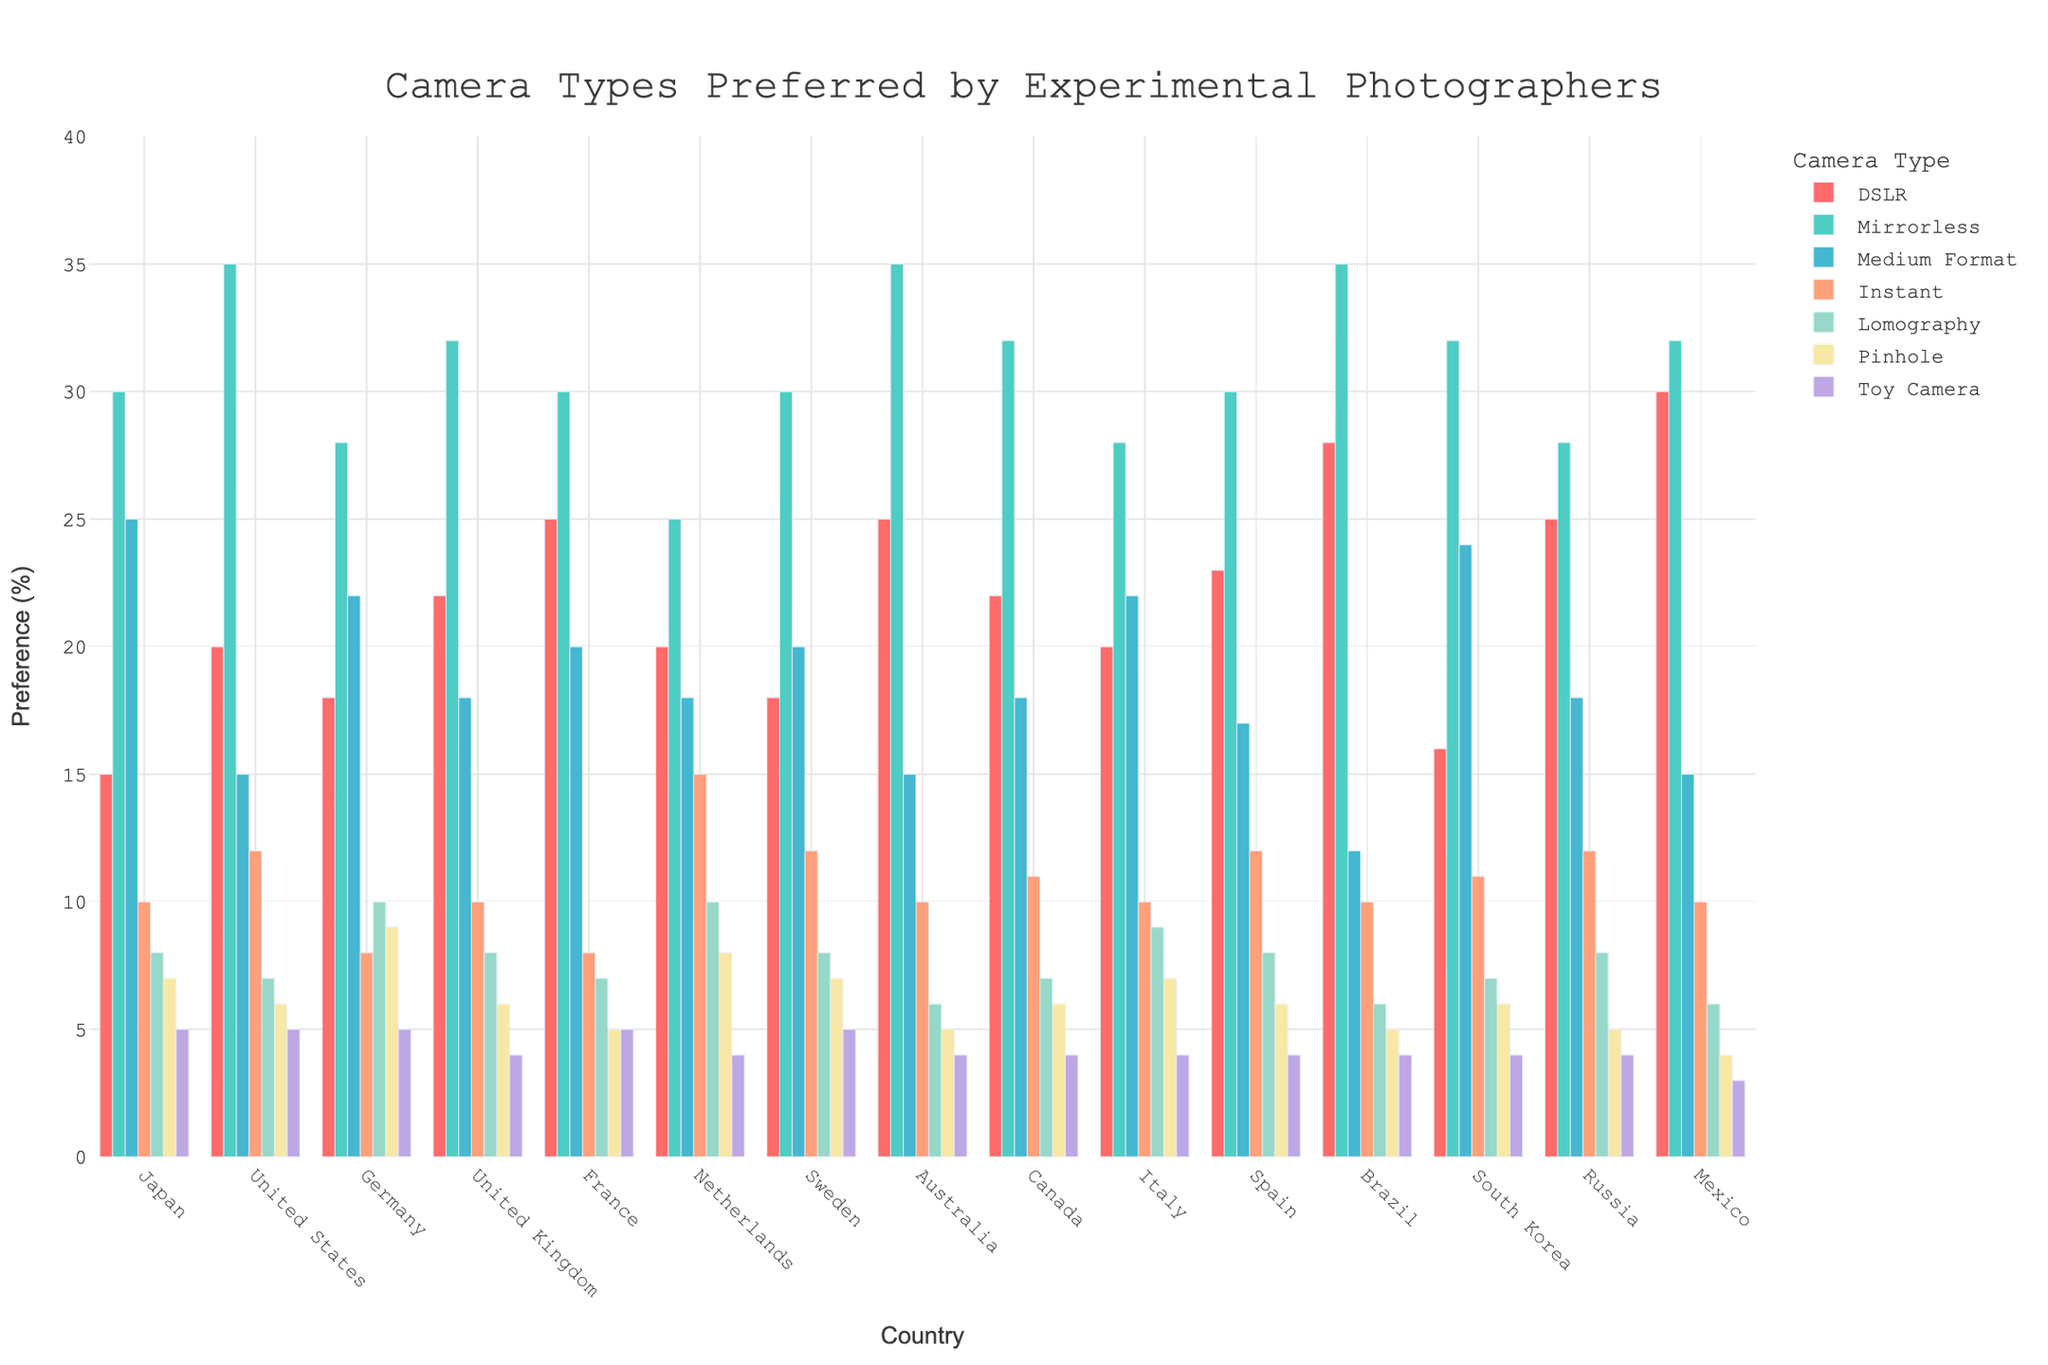Which country has the highest preference for mirrorless cameras? The highest bar in the "Mirrorless" series represents the country with the highest preference. From the chart, the United States and Brazil both have a preference bar reaching 35%.
Answer: United States and Brazil Which camera type is most preferred in Japan? Look for the tallest bar among different camera types for Japan. The "Mirrorless" bar is the tallest in the Japan series at 30%.
Answer: Mirrorless What is the sum of the preferences for Medium Format and Lomography cameras in Germany? Add the preference percentages for Medium Format (22%) and Lomography (10%) in Germany. 22 + 10 = 32.
Answer: 32 Which country has a higher preference for pinhole cameras, Germany or Sweden? Compare the heights of the bars for Pinhole cameras in Germany (9%) and Sweden (7%). The bar for Germany is higher.
Answer: Germany Does the preference for Instant cameras exceed that of Toy Cameras in the United Kingdom? Compare the heights of the bars for Instant (10%) and Toy Cameras (4%) in the United Kingdom. The Instant camera bar is higher.
Answer: Yes Which camera type has the lowest preference in France? Identify the shortest bar in the France series. The "Toy Camera" has a bar height of 5%, which is the lowest.
Answer: Toy Camera How many countries have a preference for DSLR cameras that is greater than 20%? Sum the number of countries where the height of the DSLR bar exceeds 20%. From the chart: United States (20%), United Kingdom (22%), France (25%), Australia (25%), Spain (23%), Brazil (28%), Mexico (30%). There are 7 countries in total.
Answer: 7 What is the difference in preference for Mirrorless cameras between Japan and Italy? Subtract the preference for Mirrorless cameras in Italy (28%) from the preference in Japan (30%). 30 - 28 = 2.
Answer: 2 Which camera type has the most uniform preference across different countries? Look for the camera type whose bars are most consistent across all countries. "Toy Camera" has bars nearly equal across different countries.
Answer: Toy Camera What is the average preference percentage of Medium Format cameras in the countries listed? Sum the preferences for Medium Format across all countries and divide by the number of countries. (25+15+22+18+20+18+20+15+18+22+17+12+24+18+15)/15 = 19.4.
Answer: 19.4 